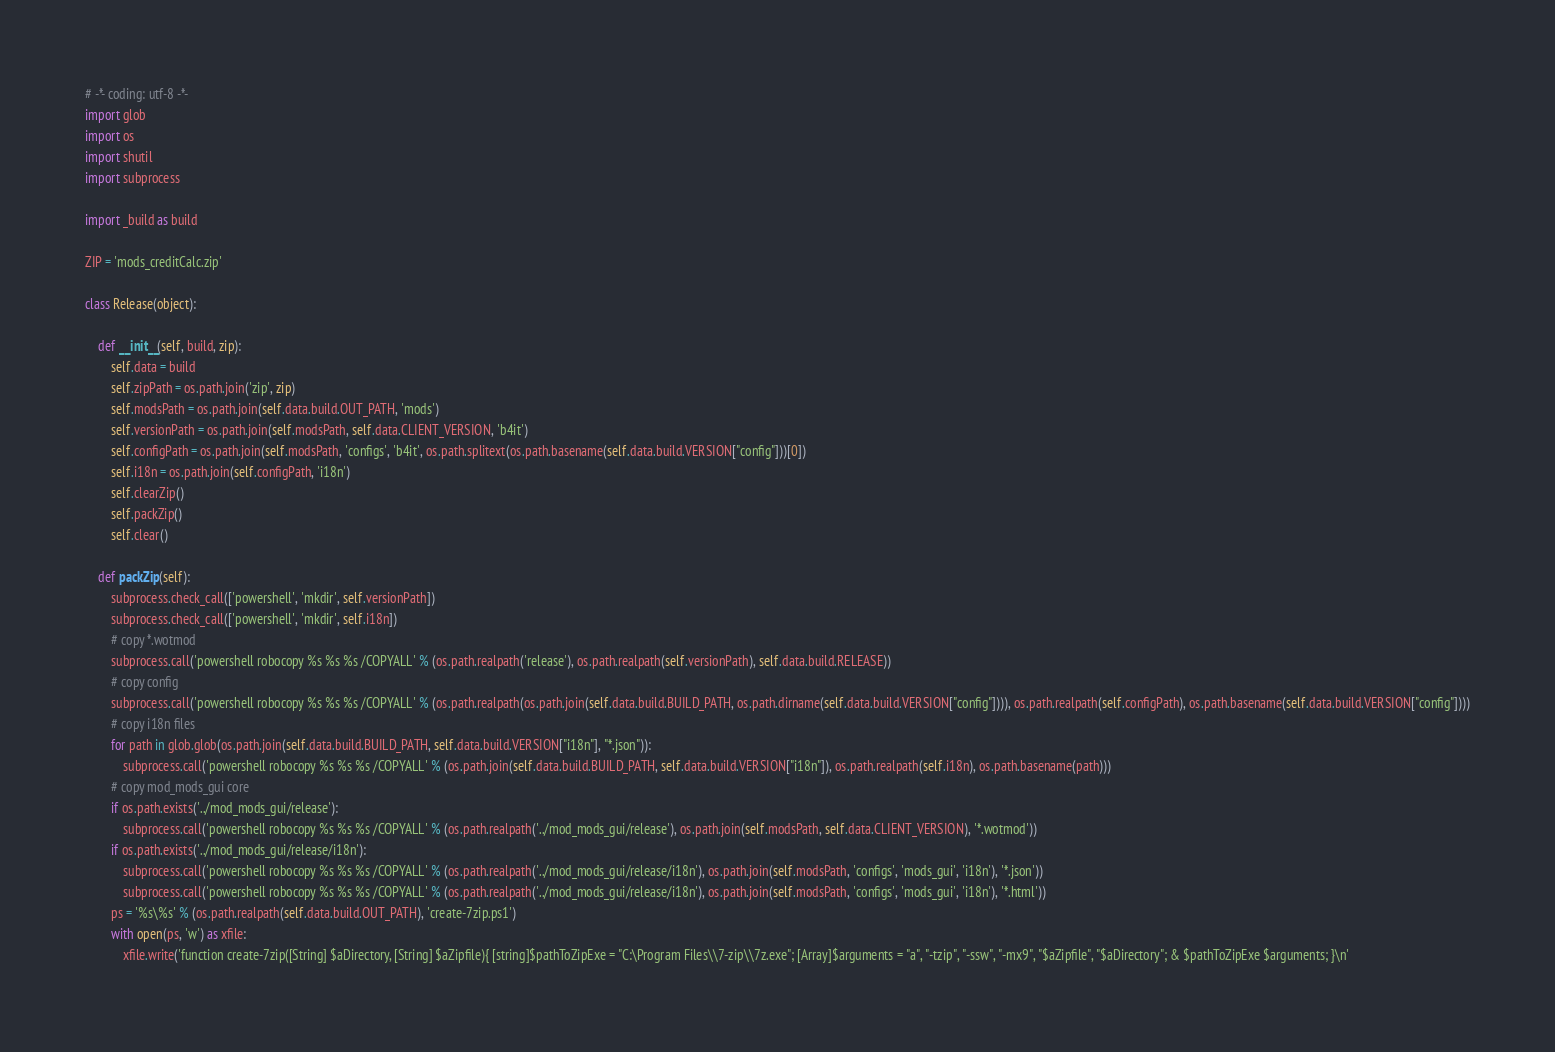<code> <loc_0><loc_0><loc_500><loc_500><_Python_># -*- coding: utf-8 -*-
import glob
import os
import shutil
import subprocess

import _build as build

ZIP = 'mods_creditCalc.zip'

class Release(object):

    def __init__(self, build, zip):
        self.data = build
        self.zipPath = os.path.join('zip', zip)
        self.modsPath = os.path.join(self.data.build.OUT_PATH, 'mods')
        self.versionPath = os.path.join(self.modsPath, self.data.CLIENT_VERSION, 'b4it')
        self.configPath = os.path.join(self.modsPath, 'configs', 'b4it', os.path.splitext(os.path.basename(self.data.build.VERSION["config"]))[0])
        self.i18n = os.path.join(self.configPath, 'i18n')
        self.clearZip()
        self.packZip()
        self.clear()

    def packZip(self):
        subprocess.check_call(['powershell', 'mkdir', self.versionPath])
        subprocess.check_call(['powershell', 'mkdir', self.i18n])
        # copy *.wotmod
        subprocess.call('powershell robocopy %s %s %s /COPYALL' % (os.path.realpath('release'), os.path.realpath(self.versionPath), self.data.build.RELEASE))
        # copy config
        subprocess.call('powershell robocopy %s %s %s /COPYALL' % (os.path.realpath(os.path.join(self.data.build.BUILD_PATH, os.path.dirname(self.data.build.VERSION["config"]))), os.path.realpath(self.configPath), os.path.basename(self.data.build.VERSION["config"])))
        # copy i18n files
        for path in glob.glob(os.path.join(self.data.build.BUILD_PATH, self.data.build.VERSION["i18n"], "*.json")):
            subprocess.call('powershell robocopy %s %s %s /COPYALL' % (os.path.join(self.data.build.BUILD_PATH, self.data.build.VERSION["i18n"]), os.path.realpath(self.i18n), os.path.basename(path)))
        # copy mod_mods_gui core
        if os.path.exists('../mod_mods_gui/release'):
            subprocess.call('powershell robocopy %s %s %s /COPYALL' % (os.path.realpath('../mod_mods_gui/release'), os.path.join(self.modsPath, self.data.CLIENT_VERSION), '*.wotmod'))
        if os.path.exists('../mod_mods_gui/release/i18n'):
            subprocess.call('powershell robocopy %s %s %s /COPYALL' % (os.path.realpath('../mod_mods_gui/release/i18n'), os.path.join(self.modsPath, 'configs', 'mods_gui', 'i18n'), '*.json'))
            subprocess.call('powershell robocopy %s %s %s /COPYALL' % (os.path.realpath('../mod_mods_gui/release/i18n'), os.path.join(self.modsPath, 'configs', 'mods_gui', 'i18n'), '*.html'))
        ps = '%s\%s' % (os.path.realpath(self.data.build.OUT_PATH), 'create-7zip.ps1')
        with open(ps, 'w') as xfile:
            xfile.write('function create-7zip([String] $aDirectory, [String] $aZipfile){ [string]$pathToZipExe = "C:\Program Files\\7-zip\\7z.exe"; [Array]$arguments = "a", "-tzip", "-ssw", "-mx9", "$aZipfile", "$aDirectory"; & $pathToZipExe $arguments; }\n'</code> 